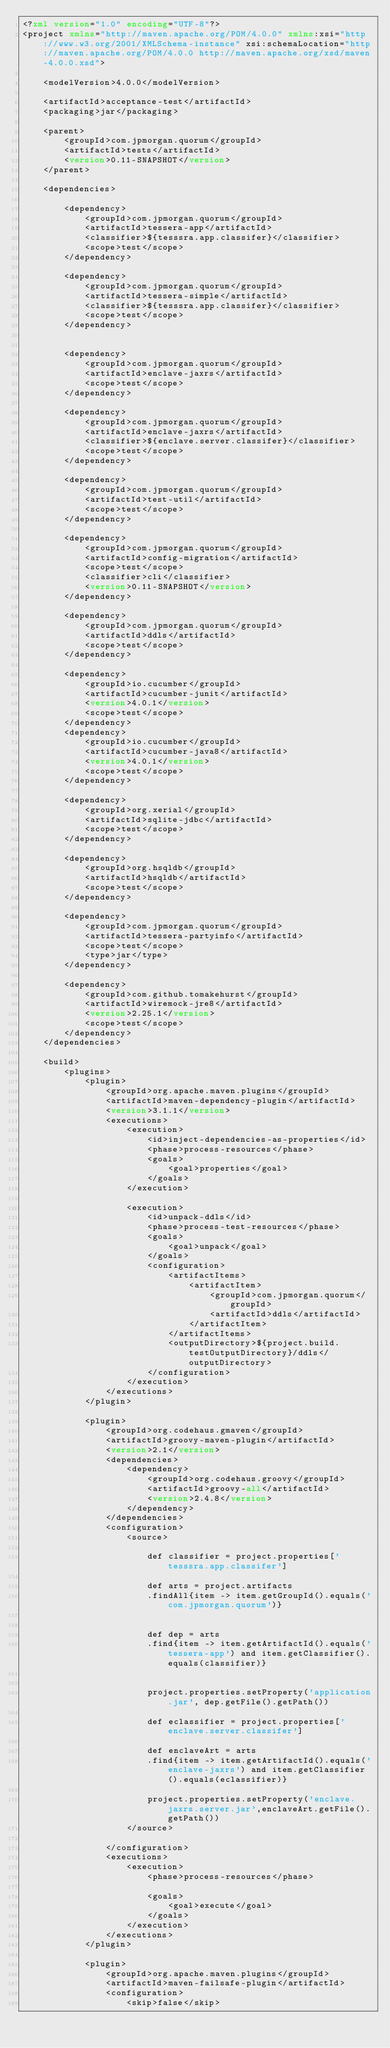<code> <loc_0><loc_0><loc_500><loc_500><_XML_><?xml version="1.0" encoding="UTF-8"?>
<project xmlns="http://maven.apache.org/POM/4.0.0" xmlns:xsi="http://www.w3.org/2001/XMLSchema-instance" xsi:schemaLocation="http://maven.apache.org/POM/4.0.0 http://maven.apache.org/xsd/maven-4.0.0.xsd">

    <modelVersion>4.0.0</modelVersion>

    <artifactId>acceptance-test</artifactId>
    <packaging>jar</packaging>

    <parent>
        <groupId>com.jpmorgan.quorum</groupId>
        <artifactId>tests</artifactId>
        <version>0.11-SNAPSHOT</version>
    </parent>

    <dependencies>

        <dependency>
            <groupId>com.jpmorgan.quorum</groupId>
            <artifactId>tessera-app</artifactId>
            <classifier>${tesssra.app.classifer}</classifier>
            <scope>test</scope>
        </dependency>

        <dependency>
            <groupId>com.jpmorgan.quorum</groupId>
            <artifactId>tessera-simple</artifactId>
            <classifier>${tesssra.app.classifer}</classifier>
            <scope>test</scope>
        </dependency>


        <dependency>
            <groupId>com.jpmorgan.quorum</groupId>
            <artifactId>enclave-jaxrs</artifactId>
            <scope>test</scope>
        </dependency>

        <dependency>
            <groupId>com.jpmorgan.quorum</groupId>
            <artifactId>enclave-jaxrs</artifactId>
            <classifier>${enclave.server.classifer}</classifier>
            <scope>test</scope>
        </dependency>

        <dependency>
            <groupId>com.jpmorgan.quorum</groupId>
            <artifactId>test-util</artifactId>
            <scope>test</scope>
        </dependency>

        <dependency>
            <groupId>com.jpmorgan.quorum</groupId>
            <artifactId>config-migration</artifactId>
            <scope>test</scope>
            <classifier>cli</classifier>
            <version>0.11-SNAPSHOT</version>
        </dependency>

        <dependency>
            <groupId>com.jpmorgan.quorum</groupId>
            <artifactId>ddls</artifactId>
            <scope>test</scope>
        </dependency>

        <dependency>
            <groupId>io.cucumber</groupId>
            <artifactId>cucumber-junit</artifactId>
            <version>4.0.1</version>
            <scope>test</scope>
        </dependency>
        <dependency>
            <groupId>io.cucumber</groupId>
            <artifactId>cucumber-java8</artifactId>
            <version>4.0.1</version>
            <scope>test</scope>
        </dependency>

        <dependency>
            <groupId>org.xerial</groupId>
            <artifactId>sqlite-jdbc</artifactId>
            <scope>test</scope>
        </dependency>

        <dependency>
            <groupId>org.hsqldb</groupId>
            <artifactId>hsqldb</artifactId>
            <scope>test</scope>
        </dependency>

        <dependency>
            <groupId>com.jpmorgan.quorum</groupId>
            <artifactId>tessera-partyinfo</artifactId>
            <scope>test</scope>
            <type>jar</type>
        </dependency>

        <dependency>
            <groupId>com.github.tomakehurst</groupId>
            <artifactId>wiremock-jre8</artifactId>
            <version>2.25.1</version>
            <scope>test</scope>
        </dependency>
    </dependencies>

    <build>
        <plugins>
            <plugin>
                <groupId>org.apache.maven.plugins</groupId>
                <artifactId>maven-dependency-plugin</artifactId>
                <version>3.1.1</version>
                <executions>
                    <execution>
                        <id>inject-dependencies-as-properties</id>
                        <phase>process-resources</phase>
                        <goals>
                            <goal>properties</goal>
                        </goals>
                    </execution>

                    <execution>
                        <id>unpack-ddls</id>
                        <phase>process-test-resources</phase>
                        <goals>
                            <goal>unpack</goal>
                        </goals>
                        <configuration>
                            <artifactItems>
                                <artifactItem>
                                    <groupId>com.jpmorgan.quorum</groupId>
                                    <artifactId>ddls</artifactId>
                                </artifactItem>
                            </artifactItems>
                            <outputDirectory>${project.build.testOutputDirectory}/ddls</outputDirectory>
                        </configuration>
                    </execution>
                </executions>
            </plugin>

            <plugin>
                <groupId>org.codehaus.gmaven</groupId>
                <artifactId>groovy-maven-plugin</artifactId>
                <version>2.1</version>
                <dependencies>
                    <dependency>
                        <groupId>org.codehaus.groovy</groupId>
                        <artifactId>groovy-all</artifactId>
                        <version>2.4.8</version>
                    </dependency>
                </dependencies>
                <configuration>
                    <source>

                        def classifier = project.properties['tesssra.app.classifer']

                        def arts = project.artifacts
                        .findAll{item -> item.getGroupId().equals('com.jpmorgan.quorum')}


                        def dep = arts
                        .find{item -> item.getArtifactId().equals('tessera-app') and item.getClassifier().equals(classifier)}


                        project.properties.setProperty('application.jar', dep.getFile().getPath())

                        def eclassifier = project.properties['enclave.server.classifer']

                        def enclaveArt = arts
                        .find{item -> item.getArtifactId().equals('enclave-jaxrs') and item.getClassifier().equals(eclassifier)}

                        project.properties.setProperty('enclave.jaxrs.server.jar',enclaveArt.getFile().getPath())
                    </source>

                </configuration>
                <executions>
                    <execution>
                        <phase>process-resources</phase>

                        <goals>
                            <goal>execute</goal>
                        </goals>
                    </execution>
                </executions>
            </plugin>

            <plugin>
                <groupId>org.apache.maven.plugins</groupId>
                <artifactId>maven-failsafe-plugin</artifactId>
                <configuration>
                    <skip>false</skip></code> 